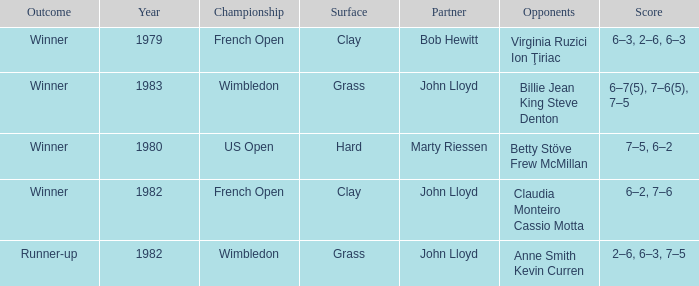Who were the opponents that led to an outcome of winner on a grass surface? Billie Jean King Steve Denton. 